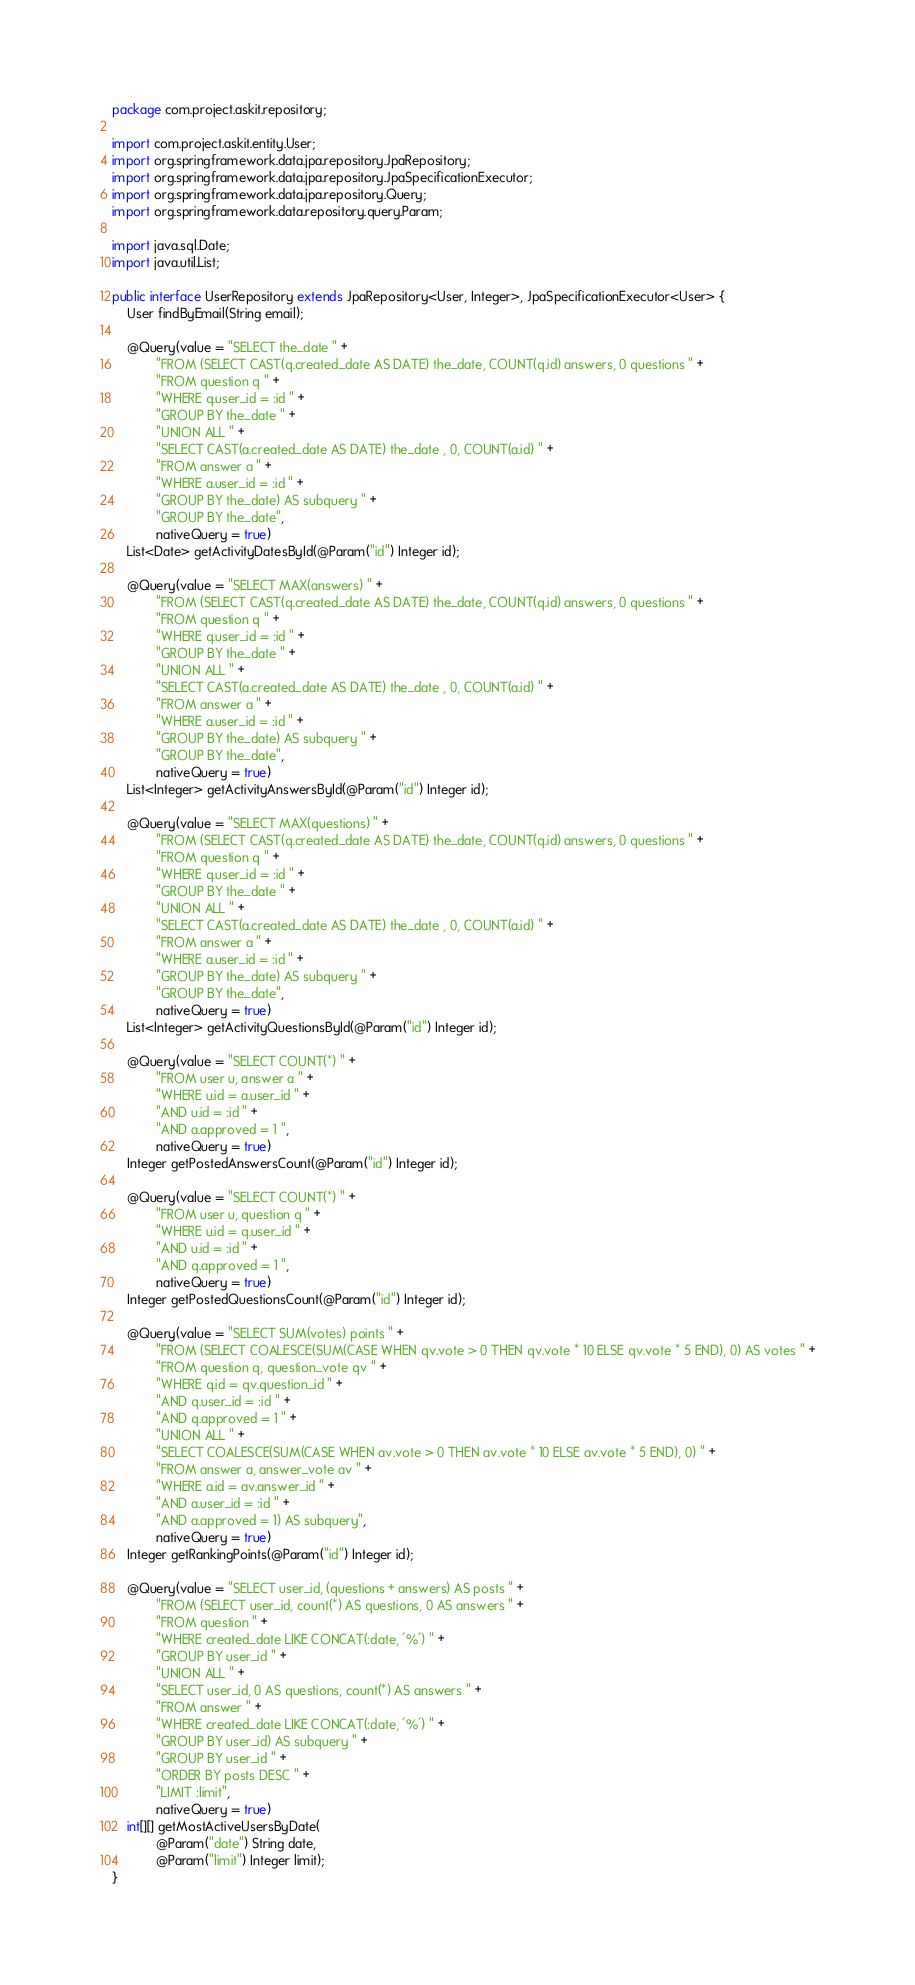Convert code to text. <code><loc_0><loc_0><loc_500><loc_500><_Java_>package com.project.askit.repository;

import com.project.askit.entity.User;
import org.springframework.data.jpa.repository.JpaRepository;
import org.springframework.data.jpa.repository.JpaSpecificationExecutor;
import org.springframework.data.jpa.repository.Query;
import org.springframework.data.repository.query.Param;

import java.sql.Date;
import java.util.List;

public interface UserRepository extends JpaRepository<User, Integer>, JpaSpecificationExecutor<User> {
    User findByEmail(String email);

    @Query(value = "SELECT the_date " +
            "FROM (SELECT CAST(q.created_date AS DATE) the_date, COUNT(q.id) answers, 0 questions " +
            "FROM question q " +
            "WHERE q.user_id = :id " +
            "GROUP BY the_date " +
            "UNION ALL " +
            "SELECT CAST(a.created_date AS DATE) the_date , 0, COUNT(a.id) " +
            "FROM answer a " +
            "WHERE a.user_id = :id " +
            "GROUP BY the_date) AS subquery " +
            "GROUP BY the_date",
            nativeQuery = true)
    List<Date> getActivityDatesById(@Param("id") Integer id);

    @Query(value = "SELECT MAX(answers) " +
            "FROM (SELECT CAST(q.created_date AS DATE) the_date, COUNT(q.id) answers, 0 questions " +
            "FROM question q " +
            "WHERE q.user_id = :id " +
            "GROUP BY the_date " +
            "UNION ALL " +
            "SELECT CAST(a.created_date AS DATE) the_date , 0, COUNT(a.id) " +
            "FROM answer a " +
            "WHERE a.user_id = :id " +
            "GROUP BY the_date) AS subquery " +
            "GROUP BY the_date",
            nativeQuery = true)
    List<Integer> getActivityAnswersById(@Param("id") Integer id);

    @Query(value = "SELECT MAX(questions) " +
            "FROM (SELECT CAST(q.created_date AS DATE) the_date, COUNT(q.id) answers, 0 questions " +
            "FROM question q " +
            "WHERE q.user_id = :id " +
            "GROUP BY the_date " +
            "UNION ALL " +
            "SELECT CAST(a.created_date AS DATE) the_date , 0, COUNT(a.id) " +
            "FROM answer a " +
            "WHERE a.user_id = :id " +
            "GROUP BY the_date) AS subquery " +
            "GROUP BY the_date",
            nativeQuery = true)
    List<Integer> getActivityQuestionsById(@Param("id") Integer id);

    @Query(value = "SELECT COUNT(*) " +
            "FROM user u, answer a " +
            "WHERE u.id = a.user_id " +
            "AND u.id = :id " +
            "AND a.approved = 1 ",
            nativeQuery = true)
    Integer getPostedAnswersCount(@Param("id") Integer id);

    @Query(value = "SELECT COUNT(*) " +
            "FROM user u, question q " +
            "WHERE u.id = q.user_id " +
            "AND u.id = :id " +
            "AND q.approved = 1 ",
            nativeQuery = true)
    Integer getPostedQuestionsCount(@Param("id") Integer id);

    @Query(value = "SELECT SUM(votes) points " +
            "FROM (SELECT COALESCE(SUM(CASE WHEN qv.vote > 0 THEN qv.vote * 10 ELSE qv.vote * 5 END), 0) AS votes " +
            "FROM question q, question_vote qv " +
            "WHERE q.id = qv.question_id " +
            "AND q.user_id = :id " +
            "AND q.approved = 1 " +
            "UNION ALL " +
            "SELECT COALESCE(SUM(CASE WHEN av.vote > 0 THEN av.vote * 10 ELSE av.vote * 5 END), 0) " +
            "FROM answer a, answer_vote av " +
            "WHERE a.id = av.answer_id " +
            "AND a.user_id = :id " +
            "AND a.approved = 1) AS subquery",
            nativeQuery = true)
    Integer getRankingPoints(@Param("id") Integer id);

    @Query(value = "SELECT user_id, (questions + answers) AS posts " +
            "FROM (SELECT user_id, count(*) AS questions, 0 AS answers " +
            "FROM question " +
            "WHERE created_date LIKE CONCAT(:date, '%') " +
            "GROUP BY user_id " +
            "UNION ALL " +
            "SELECT user_id, 0 AS questions, count(*) AS answers " +
            "FROM answer " +
            "WHERE created_date LIKE CONCAT(:date, '%') " +
            "GROUP BY user_id) AS subquery " +
            "GROUP BY user_id " +
            "ORDER BY posts DESC " +
            "LIMIT :limit",
            nativeQuery = true)
    int[][] getMostActiveUsersByDate(
            @Param("date") String date,
            @Param("limit") Integer limit);
}</code> 